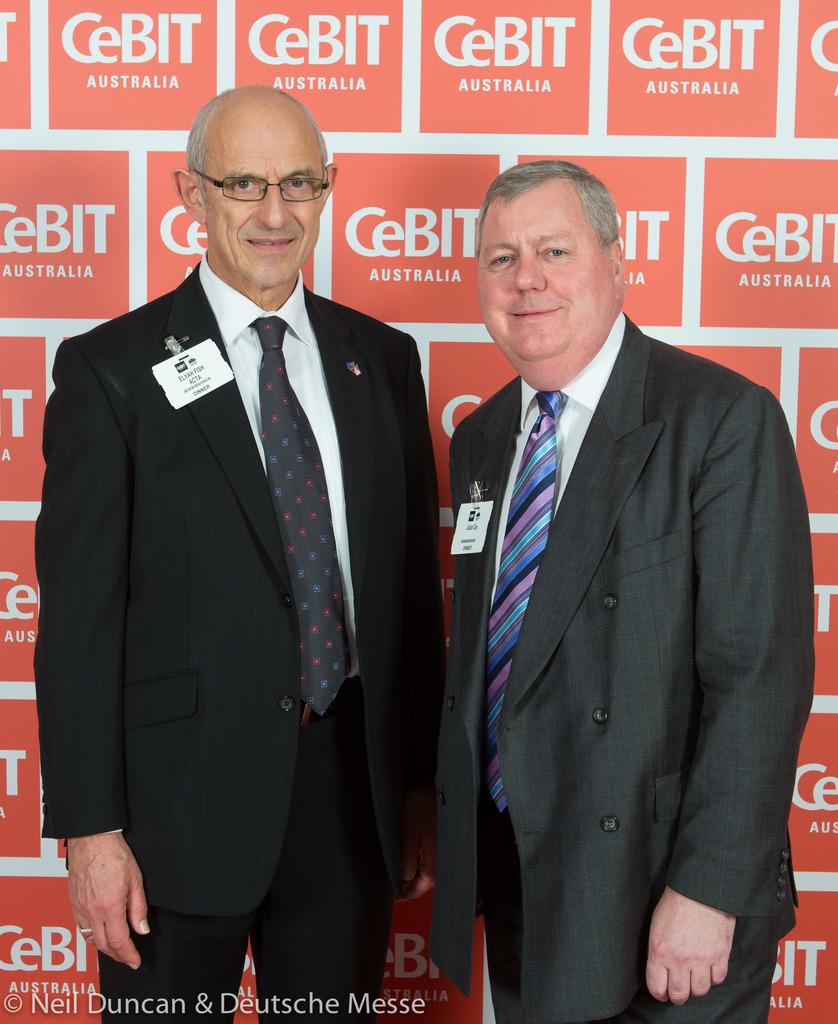How many people are in the image? There are two persons in the image. What expressions do the persons have on their faces? The persons are wearing smiles on their faces. What can be seen behind the persons? There is a banner behind the persons. What is written at the bottom of the image? There is some text written at the bottom of the image. Can you see any boats in the harbor in the image? There is no harbor or boats present in the image. What type of knot is the person tying in the image? There is no person tying a knot in the image; the persons are wearing smiles on their faces. 